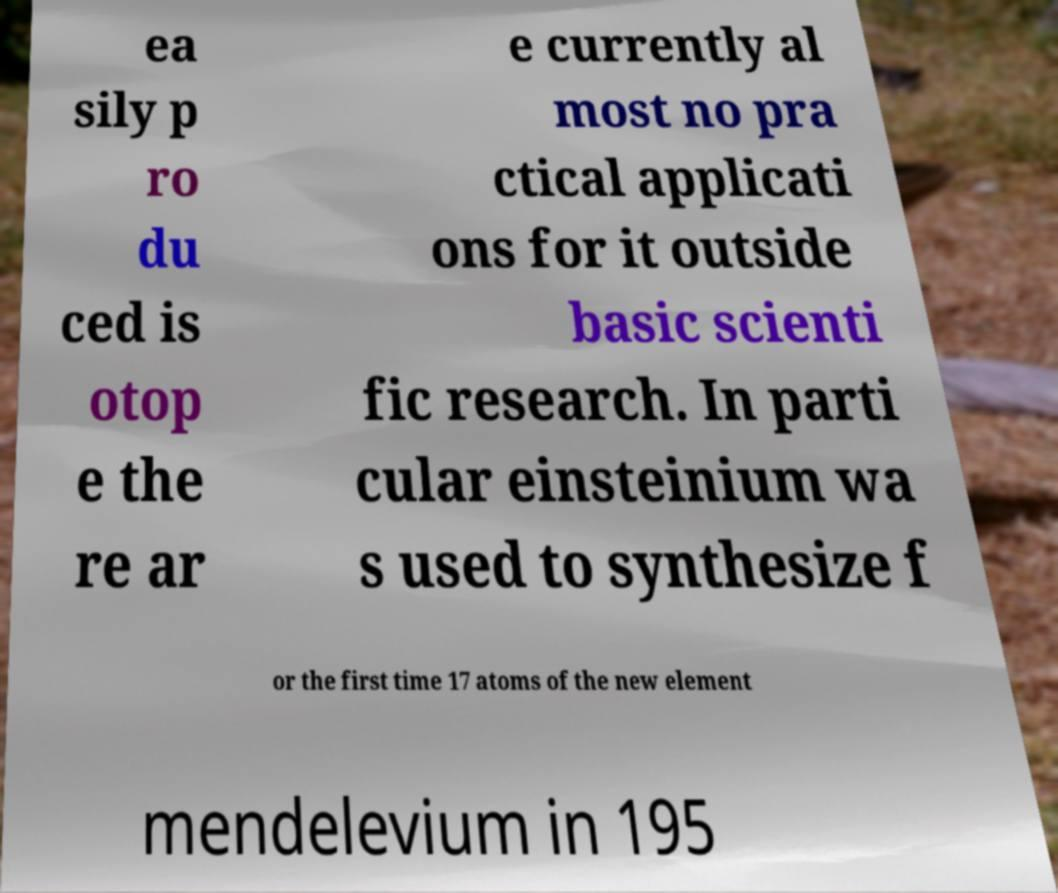Could you assist in decoding the text presented in this image and type it out clearly? ea sily p ro du ced is otop e the re ar e currently al most no pra ctical applicati ons for it outside basic scienti fic research. In parti cular einsteinium wa s used to synthesize f or the first time 17 atoms of the new element mendelevium in 195 